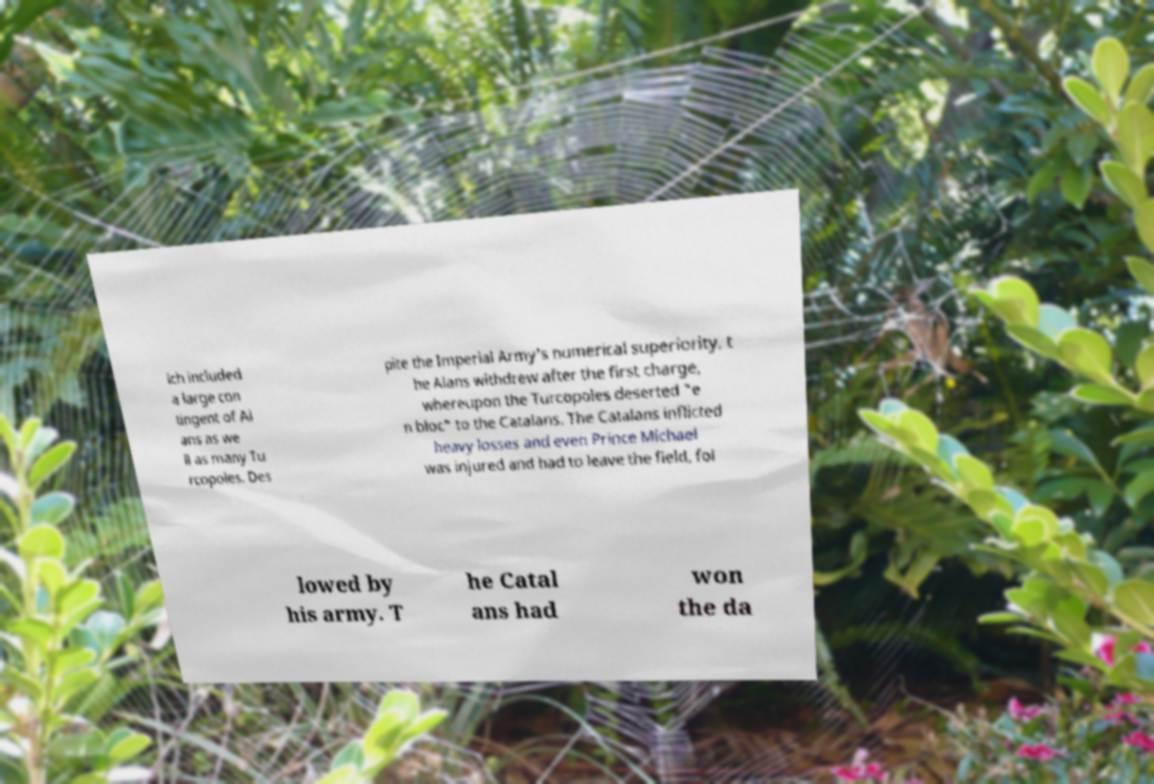Please read and relay the text visible in this image. What does it say? ich included a large con tingent of Al ans as we ll as many Tu rcopoles. Des pite the Imperial Army's numerical superiority, t he Alans withdrew after the first charge, whereupon the Turcopoles deserted "e n bloc" to the Catalans. The Catalans inflicted heavy losses and even Prince Michael was injured and had to leave the field, fol lowed by his army. T he Catal ans had won the da 